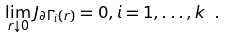Convert formula to latex. <formula><loc_0><loc_0><loc_500><loc_500>\lim _ { r \downarrow 0 } J _ { \partial \Gamma _ { i } ( r ) } = 0 , i = 1 , \dots , k \ .</formula> 